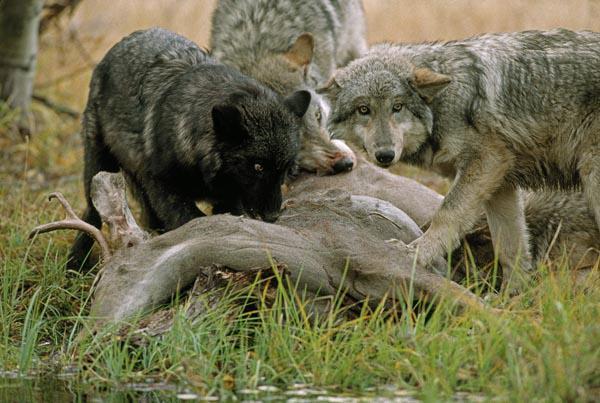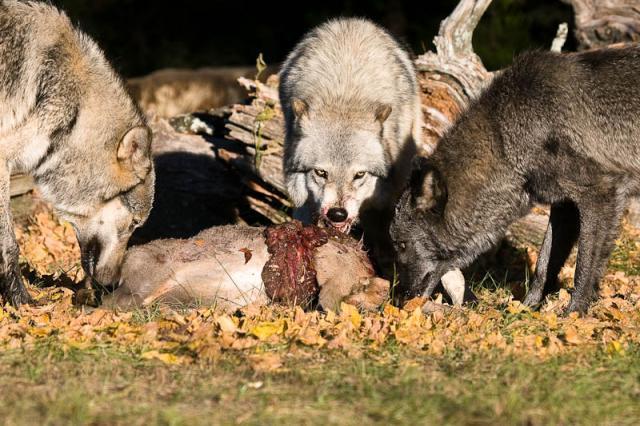The first image is the image on the left, the second image is the image on the right. Evaluate the accuracy of this statement regarding the images: "The wild dogs in the image on the right are feeding on their prey.". Is it true? Answer yes or no. Yes. The first image is the image on the left, the second image is the image on the right. Given the left and right images, does the statement "Two or more wolves are eating an animal carcass together." hold true? Answer yes or no. Yes. 